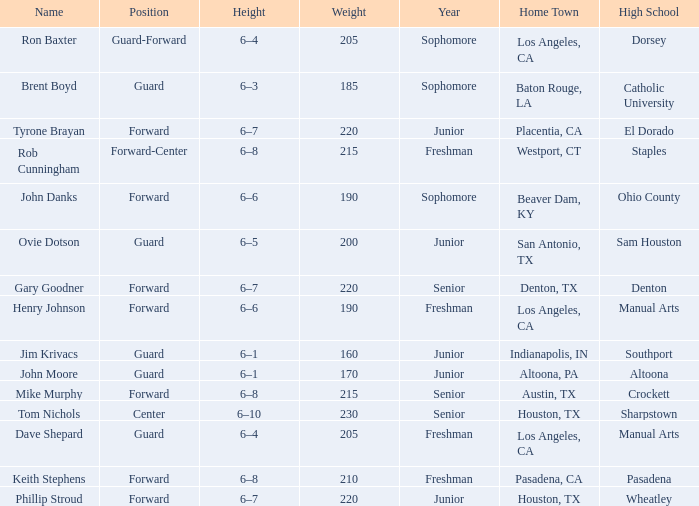What is the Name with a Year with freshman, and a Home Town with los angeles, ca, and a Height of 6–4? Dave Shepard. 